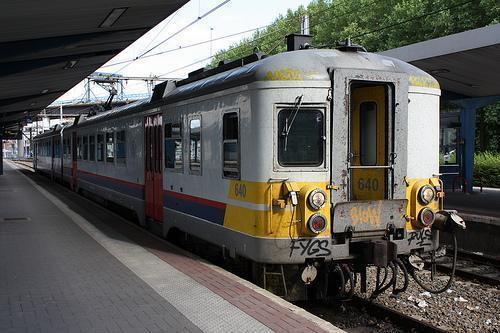How many red lights are on the end of the train?
Give a very brief answer. 2. 